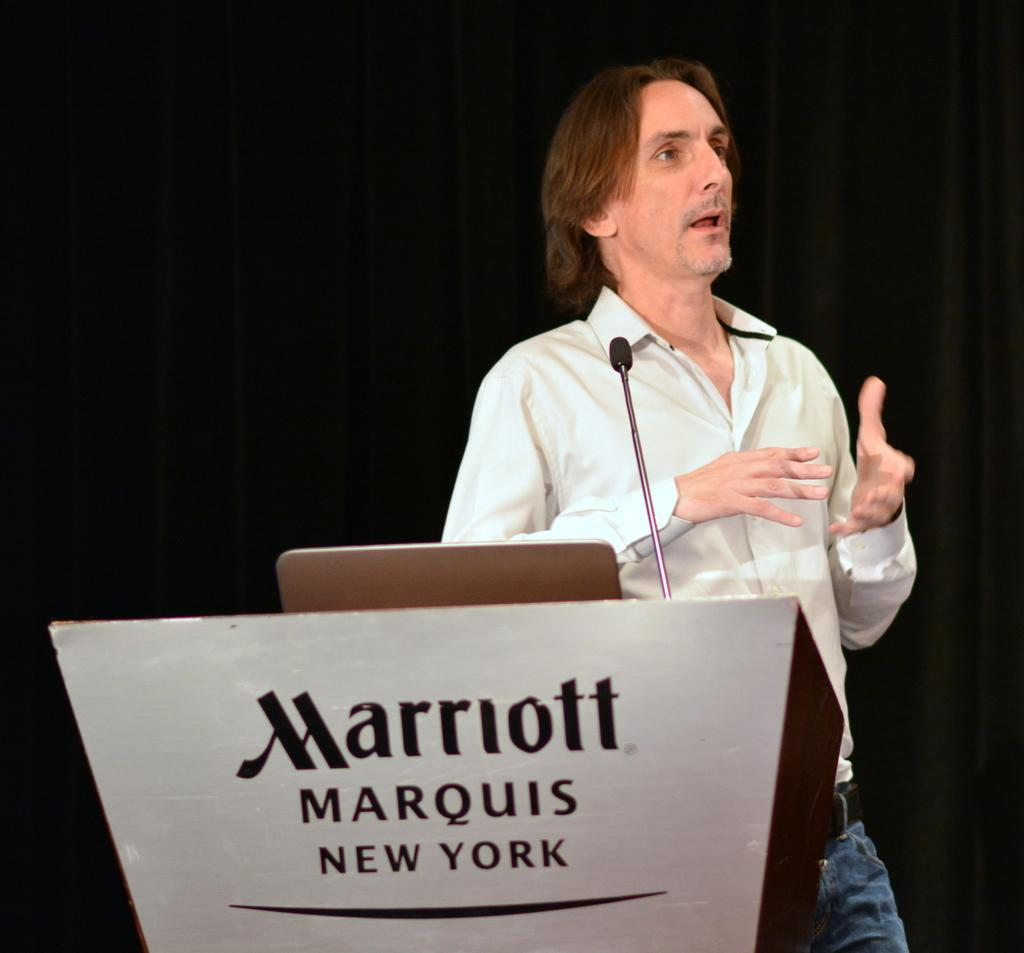What is the main object in the image? There is a podium in the image. What is written on the podium? Text is written on the podium. What is placed on top of the podium? There is an object on the podium. What device is present for amplifying sound? There is a microphone in the image. What is the person in the image doing? A person is talking in the image. How would you describe the lighting in the image? The background of the image is dark. What type of quiver is visible on the podium in the image? There is no quiver present on the podium in the image. Who is the representative speaking at the event in the image? The provided facts do not mention a specific representative or event, so we cannot determine who is speaking. 